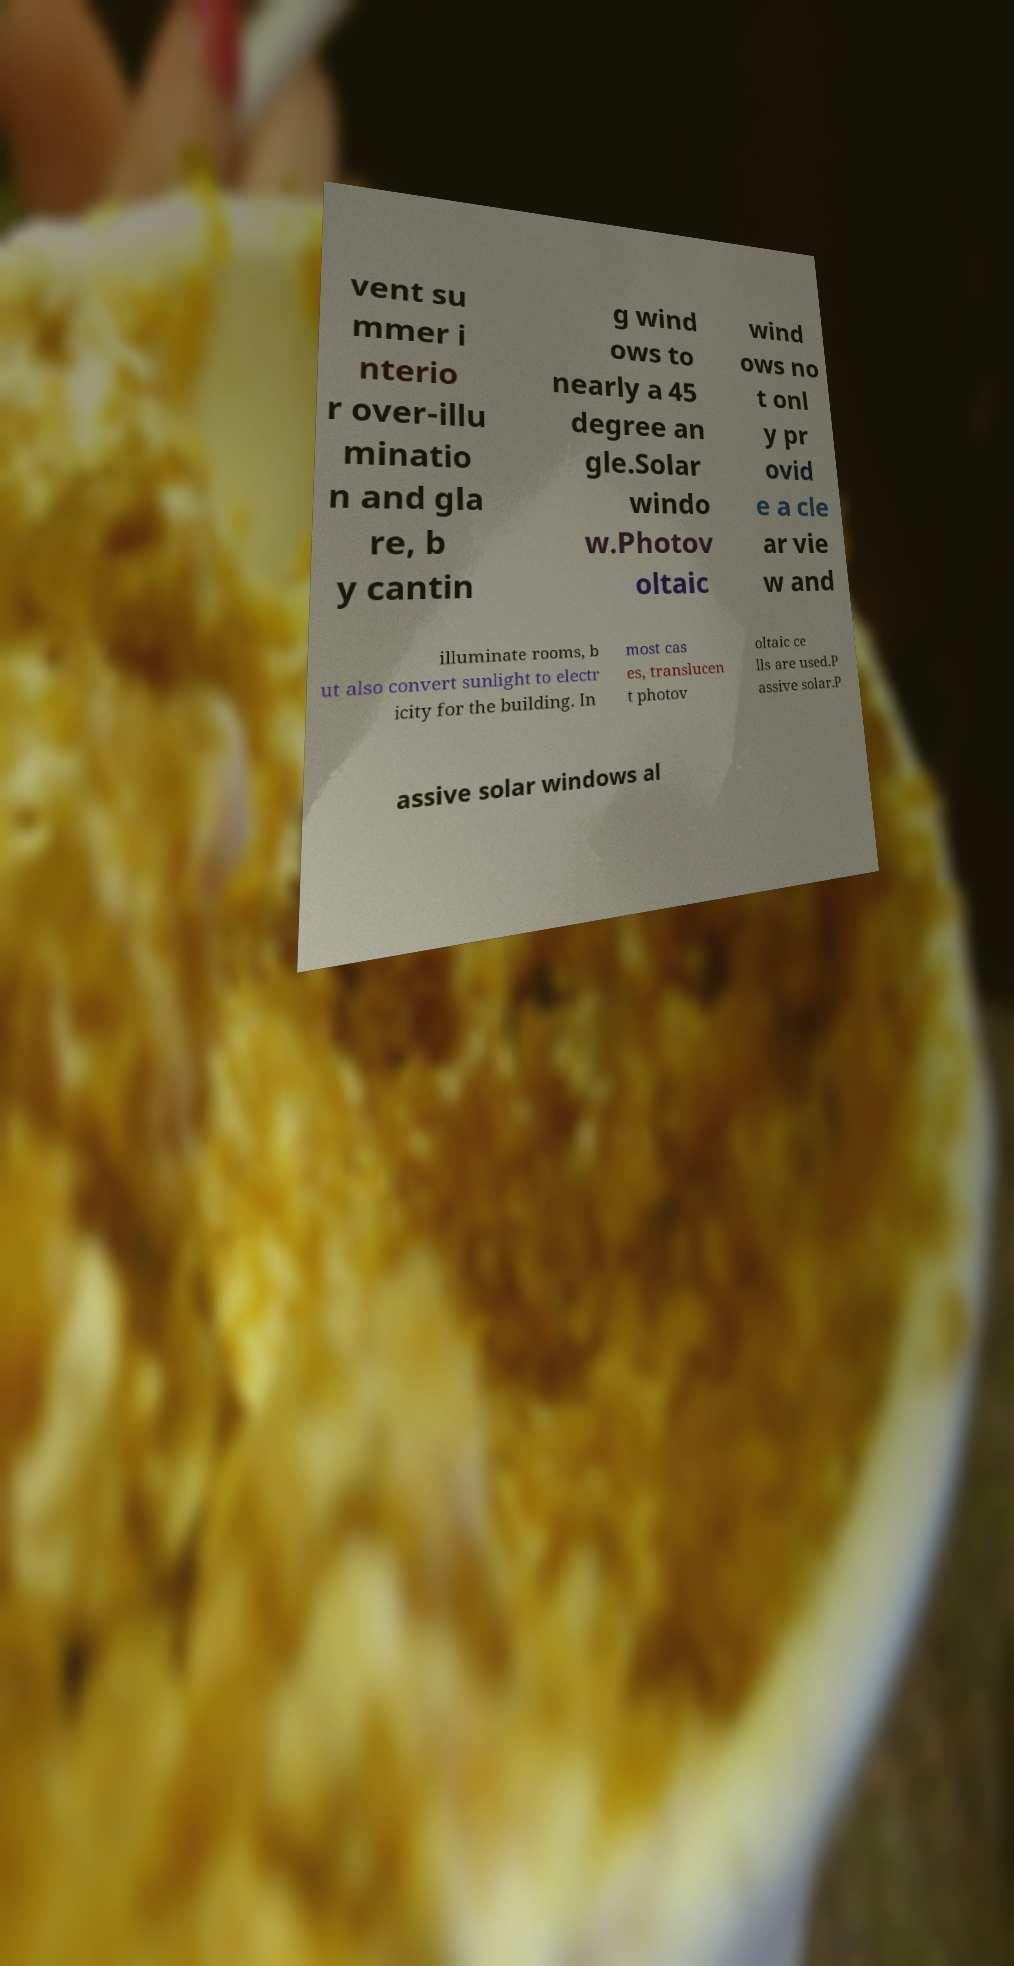For documentation purposes, I need the text within this image transcribed. Could you provide that? vent su mmer i nterio r over-illu minatio n and gla re, b y cantin g wind ows to nearly a 45 degree an gle.Solar windo w.Photov oltaic wind ows no t onl y pr ovid e a cle ar vie w and illuminate rooms, b ut also convert sunlight to electr icity for the building. In most cas es, translucen t photov oltaic ce lls are used.P assive solar.P assive solar windows al 